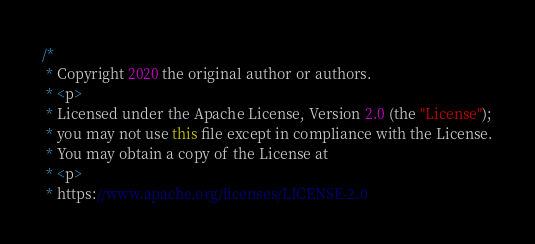<code> <loc_0><loc_0><loc_500><loc_500><_Java_>/*
 * Copyright 2020 the original author or authors.
 * <p>
 * Licensed under the Apache License, Version 2.0 (the "License");
 * you may not use this file except in compliance with the License.
 * You may obtain a copy of the License at
 * <p>
 * https://www.apache.org/licenses/LICENSE-2.0</code> 